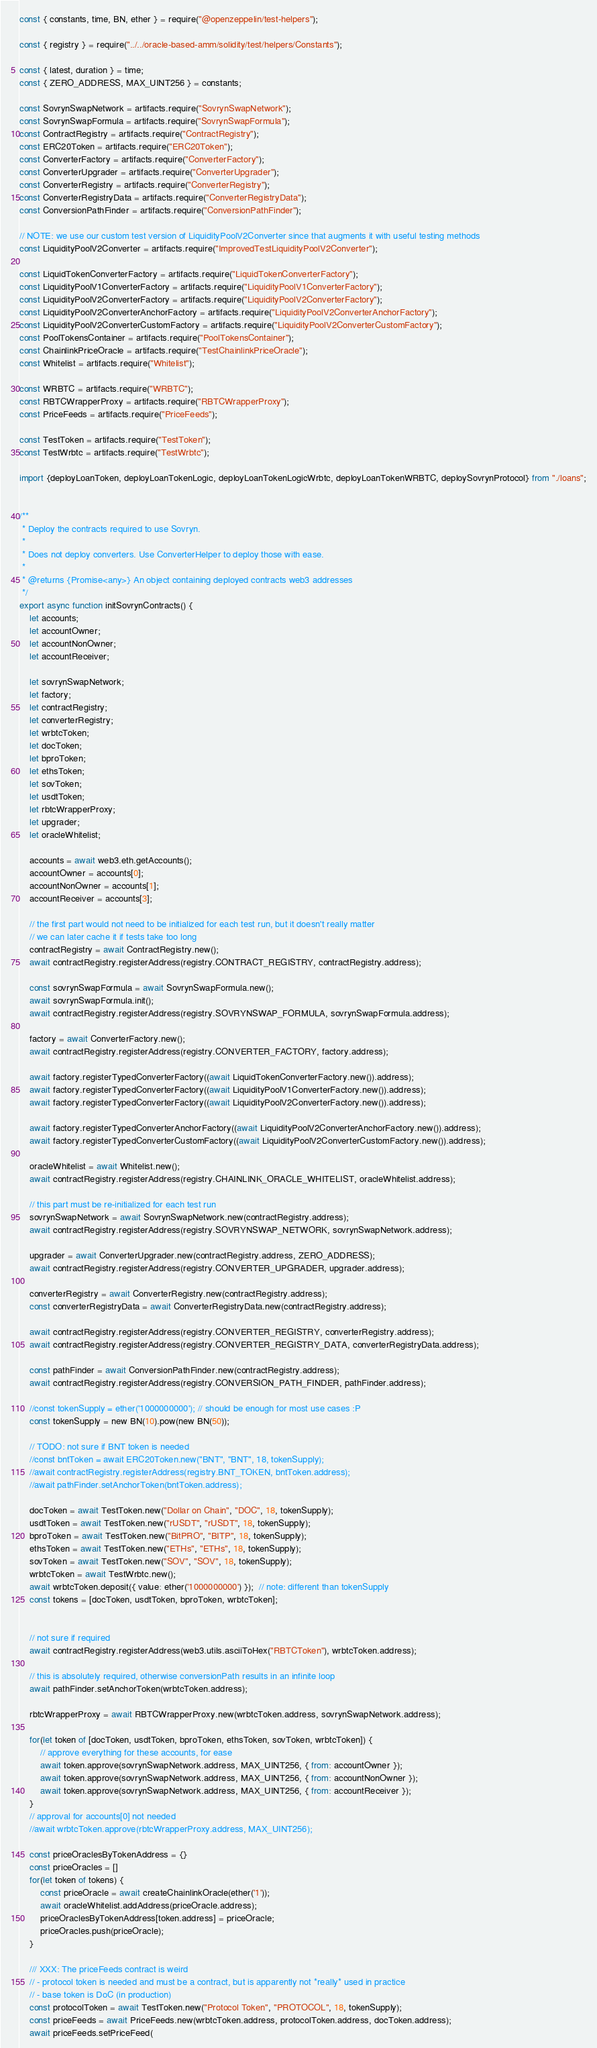Convert code to text. <code><loc_0><loc_0><loc_500><loc_500><_JavaScript_>const { constants, time, BN, ether } = require("@openzeppelin/test-helpers");

const { registry } = require("../../oracle-based-amm/solidity/test/helpers/Constants");

const { latest, duration } = time;
const { ZERO_ADDRESS, MAX_UINT256 } = constants;

const SovrynSwapNetwork = artifacts.require("SovrynSwapNetwork");
const SovrynSwapFormula = artifacts.require("SovrynSwapFormula");
const ContractRegistry = artifacts.require("ContractRegistry");
const ERC20Token = artifacts.require("ERC20Token");
const ConverterFactory = artifacts.require("ConverterFactory");
const ConverterUpgrader = artifacts.require("ConverterUpgrader");
const ConverterRegistry = artifacts.require("ConverterRegistry");
const ConverterRegistryData = artifacts.require("ConverterRegistryData");
const ConversionPathFinder = artifacts.require("ConversionPathFinder");

// NOTE: we use our custom test version of LiquidityPoolV2Converter since that augments it with useful testing methods
const LiquidityPoolV2Converter = artifacts.require("ImprovedTestLiquidityPoolV2Converter");

const LiquidTokenConverterFactory = artifacts.require("LiquidTokenConverterFactory");
const LiquidityPoolV1ConverterFactory = artifacts.require("LiquidityPoolV1ConverterFactory");
const LiquidityPoolV2ConverterFactory = artifacts.require("LiquidityPoolV2ConverterFactory");
const LiquidityPoolV2ConverterAnchorFactory = artifacts.require("LiquidityPoolV2ConverterAnchorFactory");
const LiquidityPoolV2ConverterCustomFactory = artifacts.require("LiquidityPoolV2ConverterCustomFactory");
const PoolTokensContainer = artifacts.require("PoolTokensContainer");
const ChainlinkPriceOracle = artifacts.require("TestChainlinkPriceOracle");
const Whitelist = artifacts.require("Whitelist");

const WRBTC = artifacts.require("WRBTC");
const RBTCWrapperProxy = artifacts.require("RBTCWrapperProxy");
const PriceFeeds = artifacts.require("PriceFeeds");

const TestToken = artifacts.require("TestToken");
const TestWrbtc = artifacts.require("TestWrbtc");

import {deployLoanToken, deployLoanTokenLogic, deployLoanTokenLogicWrbtc, deployLoanTokenWRBTC, deploySovrynProtocol} from "./loans";


/**
 * Deploy the contracts required to use Sovryn.
 *
 * Does not deploy converters. Use ConverterHelper to deploy those with ease.
 *
 * @returns {Promise<any>} An object containing deployed contracts web3 addresses
 */
export async function initSovrynContracts() {
    let accounts;
    let accountOwner;
    let accountNonOwner;
    let accountReceiver;

    let sovrynSwapNetwork;
    let factory;
    let contractRegistry;
    let converterRegistry;
    let wrbtcToken;
    let docToken;
    let bproToken;
    let ethsToken;
    let sovToken;
    let usdtToken;
    let rbtcWrapperProxy;
    let upgrader;
    let oracleWhitelist;

    accounts = await web3.eth.getAccounts();
    accountOwner = accounts[0];
    accountNonOwner = accounts[1];
    accountReceiver = accounts[3];

    // the first part would not need to be initialized for each test run, but it doesn't really matter
    // we can later cache it if tests take too long
    contractRegistry = await ContractRegistry.new();
    await contractRegistry.registerAddress(registry.CONTRACT_REGISTRY, contractRegistry.address);

    const sovrynSwapFormula = await SovrynSwapFormula.new();
    await sovrynSwapFormula.init();
    await contractRegistry.registerAddress(registry.SOVRYNSWAP_FORMULA, sovrynSwapFormula.address);

    factory = await ConverterFactory.new();
    await contractRegistry.registerAddress(registry.CONVERTER_FACTORY, factory.address);

    await factory.registerTypedConverterFactory((await LiquidTokenConverterFactory.new()).address);
    await factory.registerTypedConverterFactory((await LiquidityPoolV1ConverterFactory.new()).address);
    await factory.registerTypedConverterFactory((await LiquidityPoolV2ConverterFactory.new()).address);

    await factory.registerTypedConverterAnchorFactory((await LiquidityPoolV2ConverterAnchorFactory.new()).address);
    await factory.registerTypedConverterCustomFactory((await LiquidityPoolV2ConverterCustomFactory.new()).address);

    oracleWhitelist = await Whitelist.new();
    await contractRegistry.registerAddress(registry.CHAINLINK_ORACLE_WHITELIST, oracleWhitelist.address);

    // this part must be re-initialized for each test run
    sovrynSwapNetwork = await SovrynSwapNetwork.new(contractRegistry.address);
    await contractRegistry.registerAddress(registry.SOVRYNSWAP_NETWORK, sovrynSwapNetwork.address);

    upgrader = await ConverterUpgrader.new(contractRegistry.address, ZERO_ADDRESS);
    await contractRegistry.registerAddress(registry.CONVERTER_UPGRADER, upgrader.address);

    converterRegistry = await ConverterRegistry.new(contractRegistry.address);
    const converterRegistryData = await ConverterRegistryData.new(contractRegistry.address);

    await contractRegistry.registerAddress(registry.CONVERTER_REGISTRY, converterRegistry.address);
    await contractRegistry.registerAddress(registry.CONVERTER_REGISTRY_DATA, converterRegistryData.address);

    const pathFinder = await ConversionPathFinder.new(contractRegistry.address);
    await contractRegistry.registerAddress(registry.CONVERSION_PATH_FINDER, pathFinder.address);

    //const tokenSupply = ether('1000000000'); // should be enough for most use cases :P
    const tokenSupply = new BN(10).pow(new BN(50));

    // TODO: not sure if BNT token is needed
    //const bntToken = await ERC20Token.new("BNT", "BNT", 18, tokenSupply);
    //await contractRegistry.registerAddress(registry.BNT_TOKEN, bntToken.address);
    //await pathFinder.setAnchorToken(bntToken.address);

    docToken = await TestToken.new("Dollar on Chain", "DOC", 18, tokenSupply);
    usdtToken = await TestToken.new("rUSDT", "rUSDT", 18, tokenSupply);
    bproToken = await TestToken.new("BitPRO", "BITP", 18, tokenSupply);
    ethsToken = await TestToken.new("ETHs", "ETHs", 18, tokenSupply);
    sovToken = await TestToken.new("SOV", "SOV", 18, tokenSupply);
    wrbtcToken = await TestWrbtc.new();
    await wrbtcToken.deposit({ value: ether('1000000000') });  // note: different than tokenSupply
    const tokens = [docToken, usdtToken, bproToken, wrbtcToken];


    // not sure if required
    await contractRegistry.registerAddress(web3.utils.asciiToHex("RBTCToken"), wrbtcToken.address);

    // this is absolutely required, otherwise conversionPath results in an infinite loop
    await pathFinder.setAnchorToken(wrbtcToken.address);

    rbtcWrapperProxy = await RBTCWrapperProxy.new(wrbtcToken.address, sovrynSwapNetwork.address);

    for(let token of [docToken, usdtToken, bproToken, ethsToken, sovToken, wrbtcToken]) {
        // approve everything for these accounts, for ease
        await token.approve(sovrynSwapNetwork.address, MAX_UINT256, { from: accountOwner });
        await token.approve(sovrynSwapNetwork.address, MAX_UINT256, { from: accountNonOwner });
        await token.approve(sovrynSwapNetwork.address, MAX_UINT256, { from: accountReceiver });
    }
    // approval for accounts[0] not needed
    //await wrbtcToken.approve(rbtcWrapperProxy.address, MAX_UINT256);

    const priceOraclesByTokenAddress = {}
    const priceOracles = []
    for(let token of tokens) {
        const priceOracle = await createChainlinkOracle(ether('1'));
        await oracleWhitelist.addAddress(priceOracle.address);
        priceOraclesByTokenAddress[token.address] = priceOracle;
        priceOracles.push(priceOracle);
    }

    /// XXX: The priceFeeds contract is weird
    // - protocol token is needed and must be a contract, but is apparently not *really* used in practice
    // - base token is DoC (in production)
    const protocolToken = await TestToken.new("Protocol Token", "PROTOCOL", 18, tokenSupply);
    const priceFeeds = await PriceFeeds.new(wrbtcToken.address, protocolToken.address, docToken.address);
    await priceFeeds.setPriceFeed(</code> 